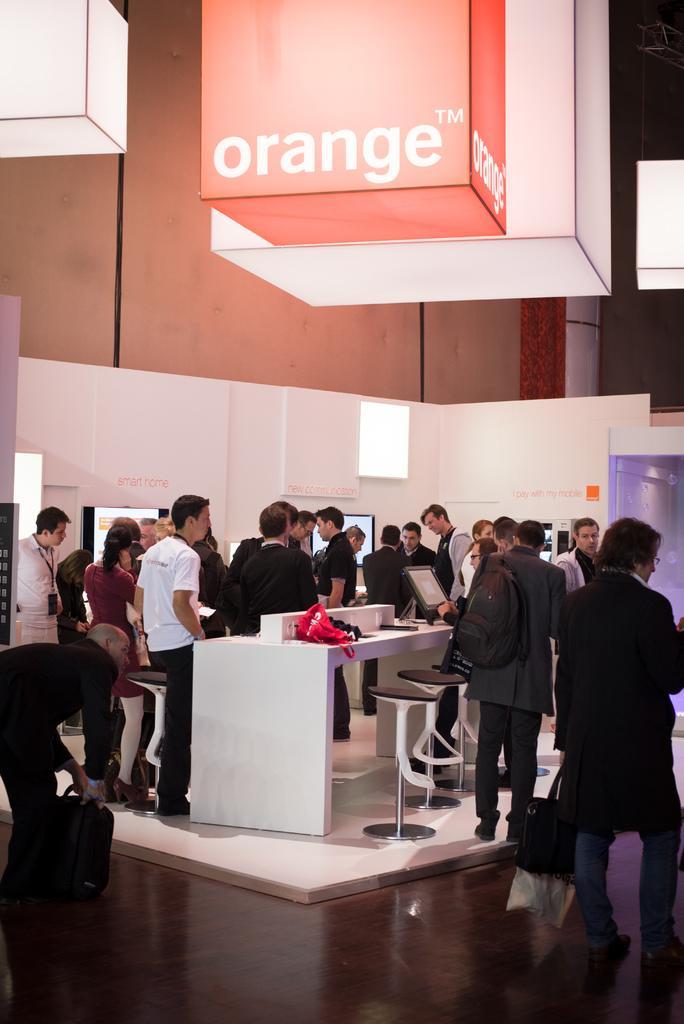Describe this image in one or two sentences. In the foreground it floor. In the center of the picture there are people, desktop, table, chairs and a white wall. At the top there are boxes like objects with light in it. In the background it is well. On the right there is a banner. On the left it is banner. 